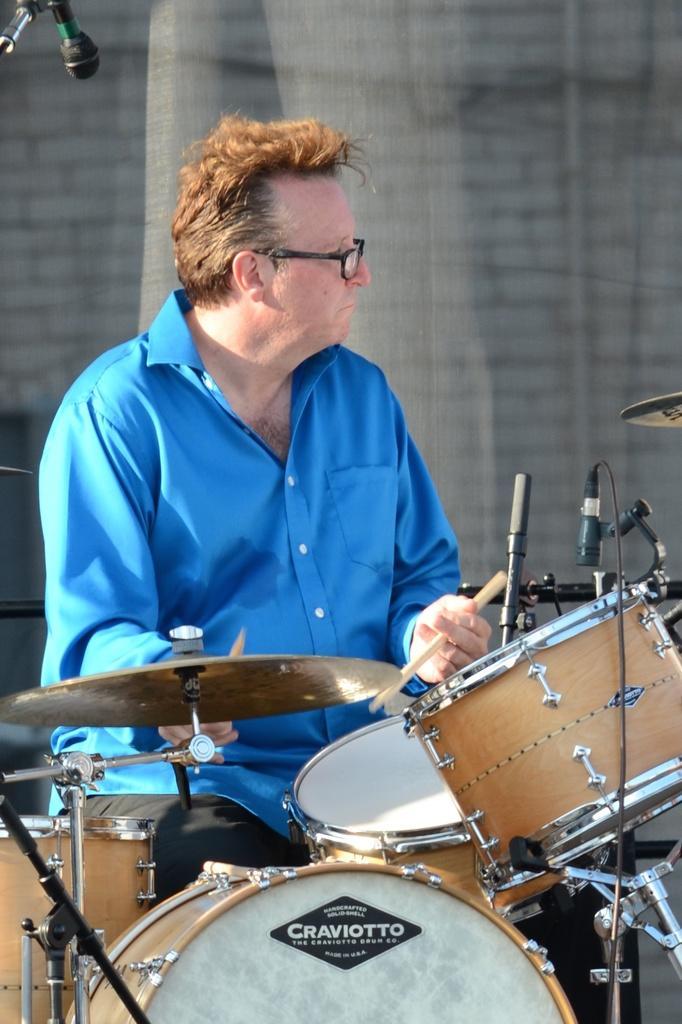In one or two sentences, can you explain what this image depicts? In this image we can see a man is playing musical instruments. Here we can see a mike. In the background we can see wall. 